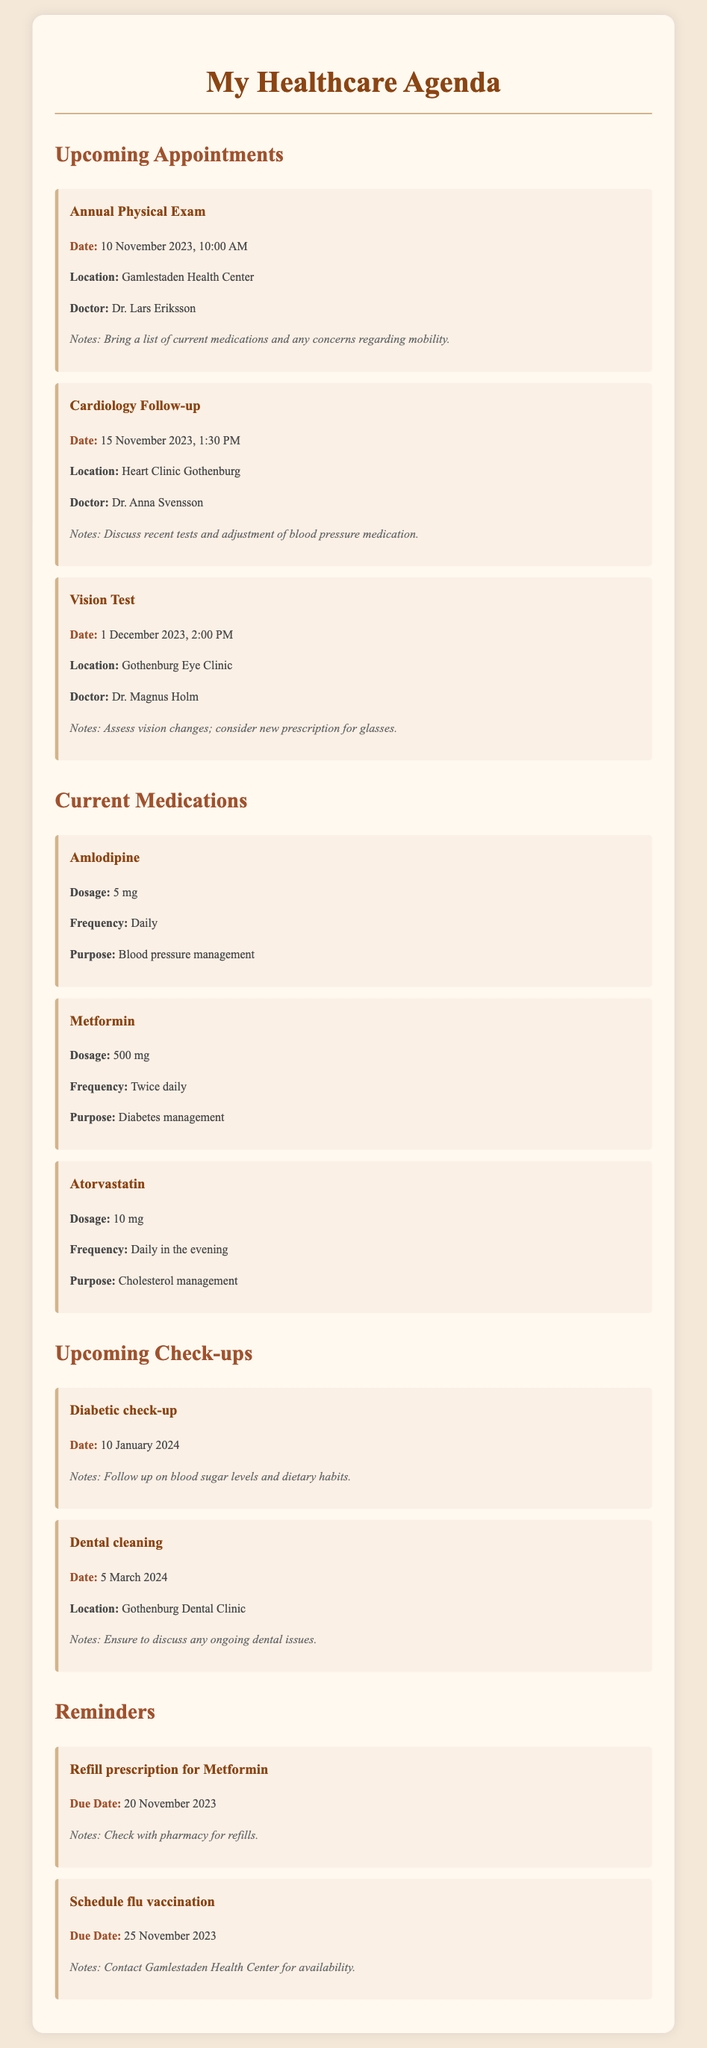What is the date of the Annual Physical Exam? The date for the Annual Physical Exam is explicitly mentioned in the document as 10 November 2023.
Answer: 10 November 2023 Who is the doctor for the Cardiology Follow-up? The document specifies that Dr. Anna Svensson is the doctor for the Cardiology Follow-up appointment.
Answer: Dr. Anna Svensson What is the dosage of Amlodipine? Amlodipine's dosage is explicitly stated in the document as 5 mg.
Answer: 5 mg When is the due date for the Metformin prescription refill? The document states that the due date for the Metformin prescription refill is 20 November 2023.
Answer: 20 November 2023 What is the location for the Vision Test? The document mentions the location for the Vision Test as Gothenburg Eye Clinic.
Answer: Gothenburg Eye Clinic How often should Atorvastatin be taken? The document specifies that Atorvastatin should be taken Daily in the evening.
Answer: Daily in the evening What should be discussed during the Dental cleaning check-up? The document mentions that ongoing dental issues should be discussed during the Dental cleaning check-up.
Answer: Ongoing dental issues How many medications are listed in the document? The document lists three medications (Amlodipine, Metformin, and Atorvastatin).
Answer: Three medications What is the purpose of Metformin? The document states that the purpose of Metformin is diabetes management.
Answer: Diabetes management 